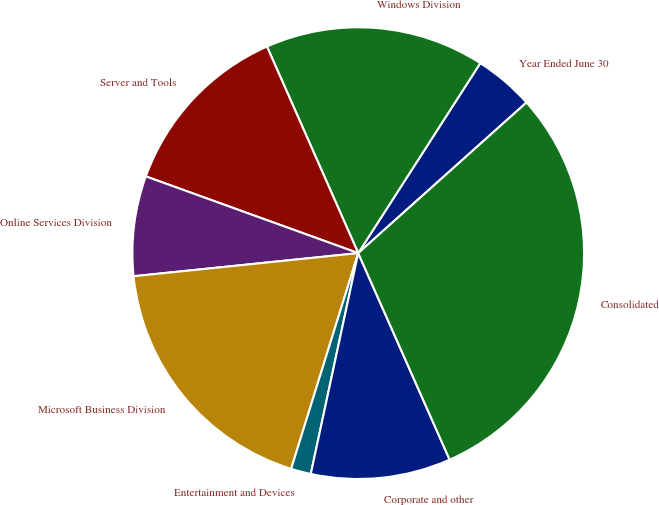Convert chart. <chart><loc_0><loc_0><loc_500><loc_500><pie_chart><fcel>Year Ended June 30<fcel>Windows Division<fcel>Server and Tools<fcel>Online Services Division<fcel>Microsoft Business Division<fcel>Entertainment and Devices<fcel>Corporate and other<fcel>Consolidated<nl><fcel>4.29%<fcel>15.71%<fcel>12.86%<fcel>7.15%<fcel>18.57%<fcel>1.43%<fcel>10.0%<fcel>29.99%<nl></chart> 